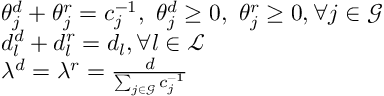Convert formula to latex. <formula><loc_0><loc_0><loc_500><loc_500>\begin{array} { r l } & { { \theta } _ { j } ^ { d } + { \theta } _ { j } ^ { r } = c _ { j } ^ { - 1 } , \ { \theta } _ { j } ^ { d } \geq 0 , \ { \theta } _ { j } ^ { r } \geq 0 , \forall j \in \mathcal { G } } \\ & { d _ { l } ^ { d } + d _ { l } ^ { r } = d _ { l } , \forall l \in \mathcal { L } } \\ & { \lambda ^ { d } = \lambda ^ { r } = \frac { d } { \sum _ { j \in \mathcal { G } } c _ { j } ^ { - 1 } } } \end{array}</formula> 